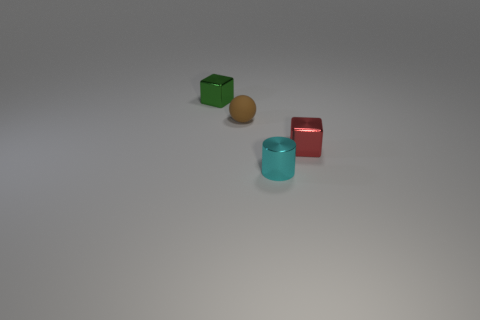Are the small thing that is behind the tiny brown sphere and the cyan object made of the same material?
Make the answer very short. Yes. What number of other metal objects have the same shape as the green thing?
Offer a terse response. 1. What number of tiny things are cylinders or brown shiny spheres?
Offer a very short reply. 1. Does the metallic block that is in front of the green cube have the same color as the small matte ball?
Provide a succinct answer. No. Do the small cube that is behind the red thing and the cube that is right of the brown matte object have the same color?
Your answer should be very brief. No. Is there a cylinder that has the same material as the brown thing?
Provide a succinct answer. No. How many purple things are either rubber objects or shiny objects?
Make the answer very short. 0. Is the number of shiny objects on the right side of the green object greater than the number of tiny rubber things?
Provide a succinct answer. Yes. Does the red metal block have the same size as the sphere?
Give a very brief answer. Yes. What is the color of the other tiny cube that is made of the same material as the small red cube?
Make the answer very short. Green. 